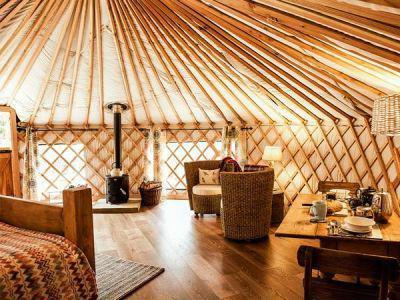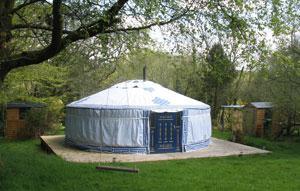The first image is the image on the left, the second image is the image on the right. For the images shown, is this caption "In one image, a yurt sits on a raised deck with wooden fencing, while the other image shows one or more yurts with outdoor table seating." true? Answer yes or no. No. The first image is the image on the left, the second image is the image on the right. Analyze the images presented: Is the assertion "The hut in the image on the right is set up on a deck." valid? Answer yes or no. Yes. 